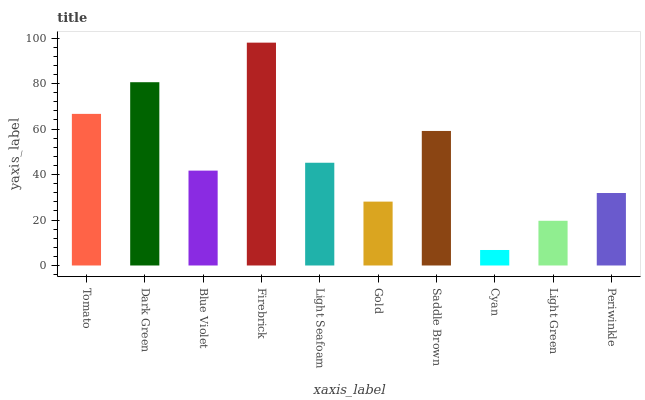Is Dark Green the minimum?
Answer yes or no. No. Is Dark Green the maximum?
Answer yes or no. No. Is Dark Green greater than Tomato?
Answer yes or no. Yes. Is Tomato less than Dark Green?
Answer yes or no. Yes. Is Tomato greater than Dark Green?
Answer yes or no. No. Is Dark Green less than Tomato?
Answer yes or no. No. Is Light Seafoam the high median?
Answer yes or no. Yes. Is Blue Violet the low median?
Answer yes or no. Yes. Is Gold the high median?
Answer yes or no. No. Is Firebrick the low median?
Answer yes or no. No. 